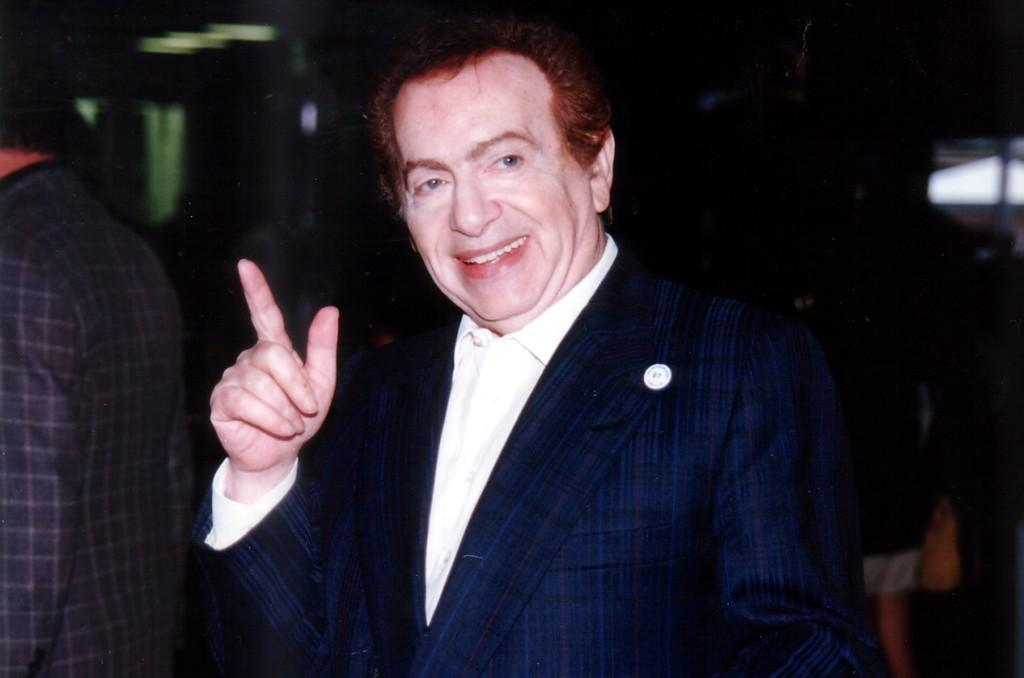Who is the main subject in the front of the image? There is a person standing in the front of the image. What is the facial expression of the person in the front? The person in the front is smiling. Can you describe the person standing on the left side of the image? There is another person standing on the left side of the image. How would you describe the background of the image? The background of the image is blurry. What type of bells can be heard ringing in the background of the image? There are no bells present in the image, and therefore no sound can be heard. 